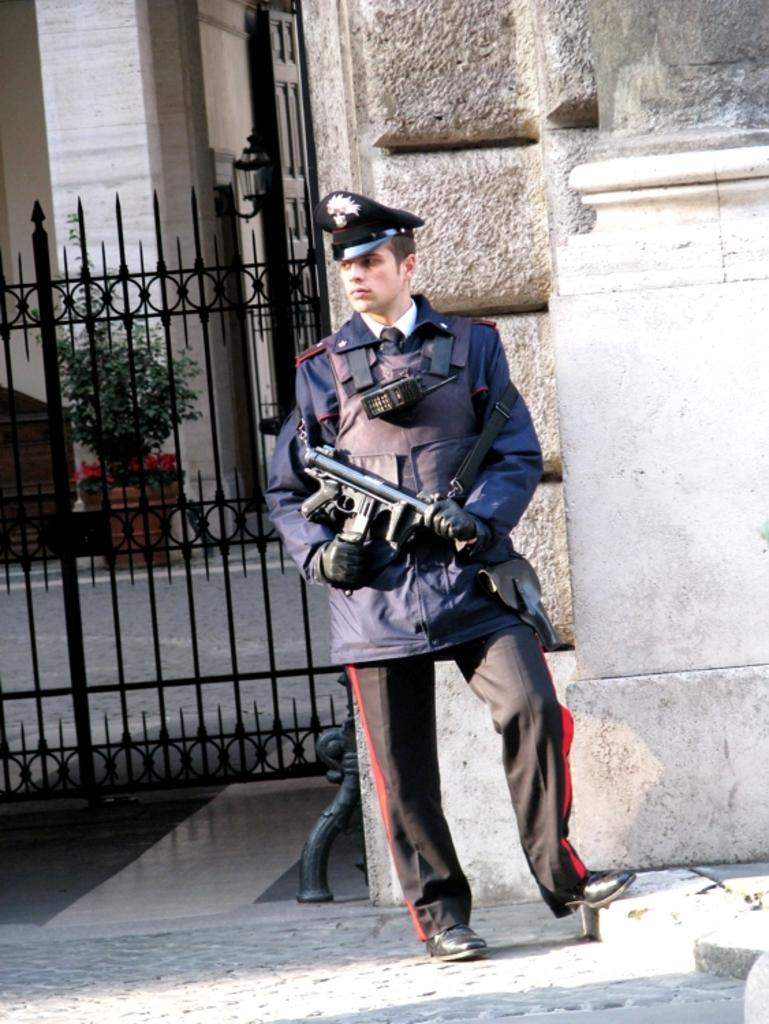What is the person in the image holding? The person is holding a gun in the image. Where is the person standing in relation to the building? The person is standing outside the building. What type of container is visible in the image? There is a tree pot in the image. What is the main entrance to the building in the image? There is a door in the image. What type of barrier is present in the image? There is an iron grill in the image. What type of vase can be seen on the person's head in the image? There is no vase present on the person's head in the image. What type of stocking is the person wearing in the image? There is no mention of stockings or any clothing items in the image. 